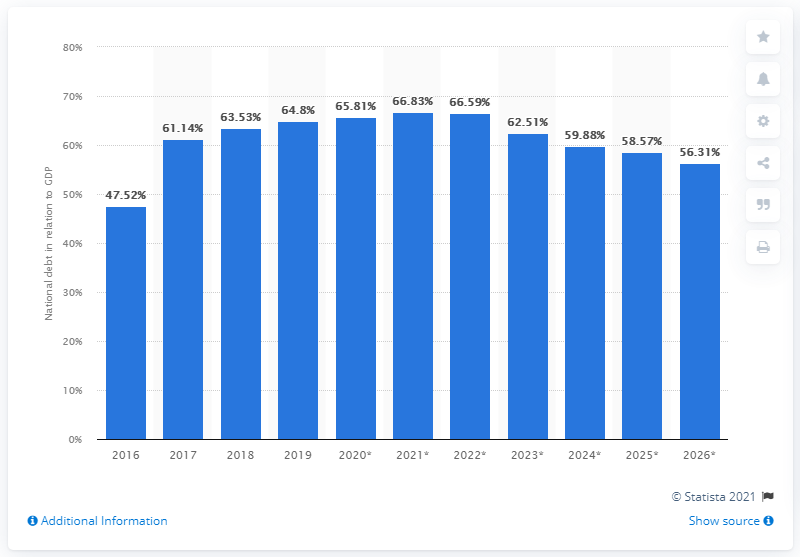Outline some significant characteristics in this image. In 2019, the national debt of Senegal accounted for 64.8% of the country's GDP. 